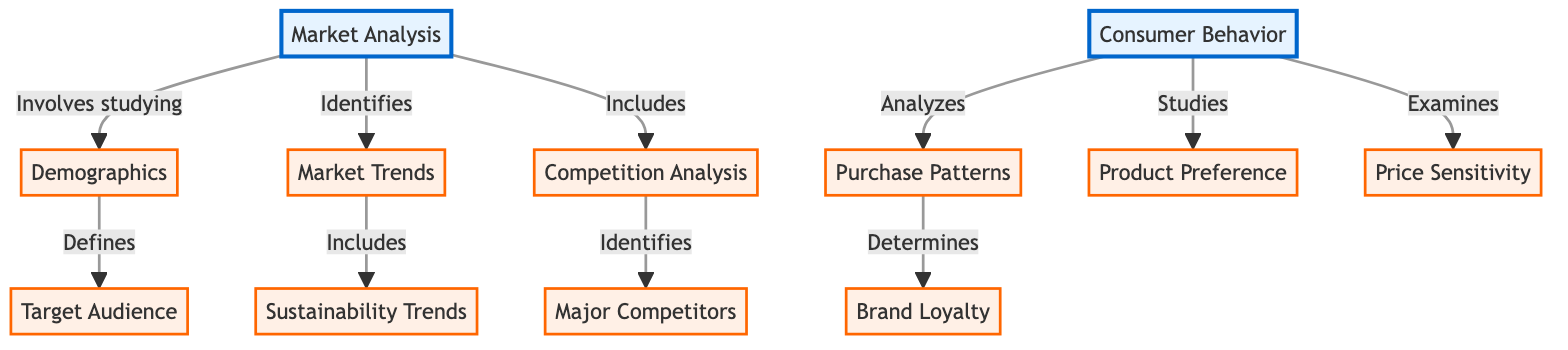What are the main components of market analysis? The diagram shows that market analysis encompasses three main components: demographics, market trends, and competition analysis. These are clearly depicted as sub-nodes connected to the main node of market analysis.
Answer: demographics, market trends, competition analysis How does market analysis relate to consumer behavior? The diagram indicates that market analysis and consumer behavior are both main components of the overall structure. There is no direct connection mentioned between them, indicating they are separate analyses but potentially complementary.
Answer: Separate analyses What is included in consumer behavior? According to the diagram, consumer behavior includes purchase patterns, product preference, and price sensitivity, which are sub-nodes linked to the consumer behavior node.
Answer: purchase patterns, product preference, price sensitivity Which component identifies major competitors? The diagram specifies that competition analysis identifies major competitors, as indicated by the arrow directing from competition analysis to major competitors, which is a sub-node of competition analysis.
Answer: competition analysis What defines the target audience? The diagram illustrates that demographics define the target audience, as shown by the arrow leading from the demographics node to the target audience sub-node.
Answer: demographics What trends are included in market trends? The diagram reveals that market trends include sustainability trends, as depicted by the connecting arrow leading from market trends to sustainability trends, showing the relationship.
Answer: sustainability trends How many components are there under consumer behavior? By examining the diagram, we can see that there are three components under consumer behavior: purchase patterns, product preference, and price sensitivity, making a total of three sub-nodes.
Answer: three What determines brand loyalty? The diagram indicates that brand loyalty is determined by purchase patterns, which is shown by the connection from purchase patterns to brand loyalty as a sub-node.
Answer: purchase patterns What does market analysis involve studying? The diagram states that market analysis involves studying demographics, as indicated by the arrow leading from market analysis to the demographics sub-node.
Answer: demographics 